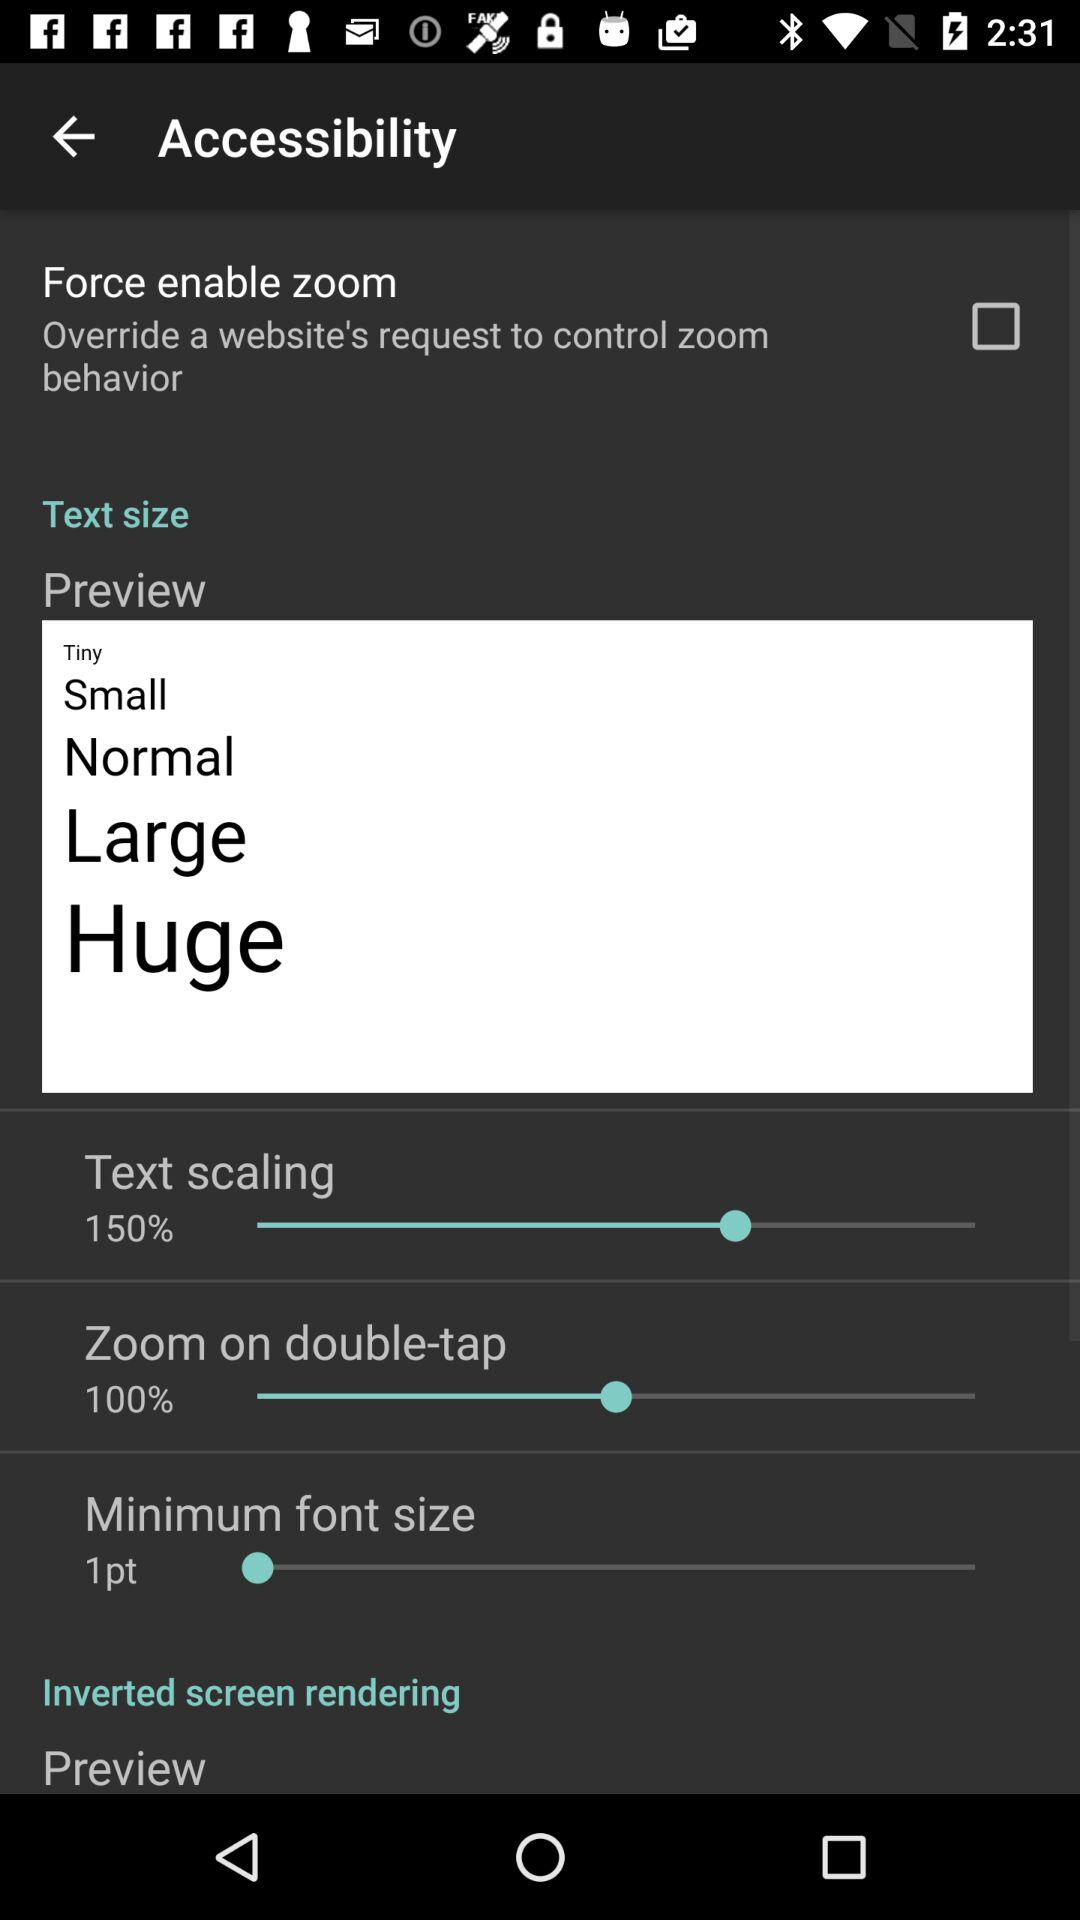How many options are there for the text size?
Answer the question using a single word or phrase. 5 